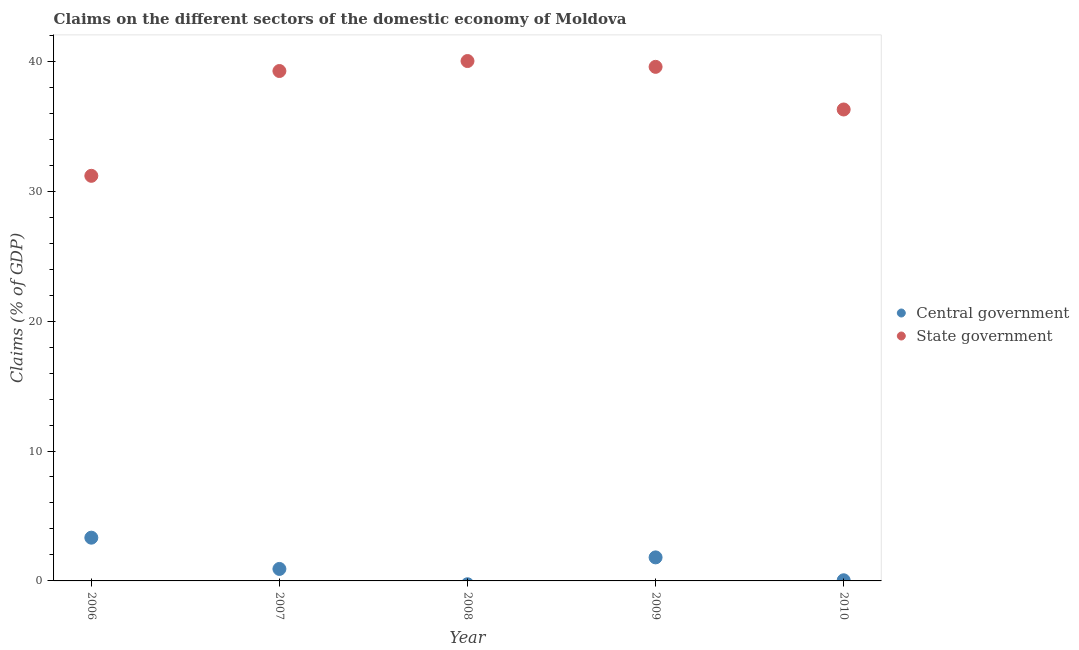How many different coloured dotlines are there?
Provide a short and direct response. 2. Is the number of dotlines equal to the number of legend labels?
Your answer should be very brief. No. What is the claims on central government in 2007?
Make the answer very short. 0.92. Across all years, what is the maximum claims on state government?
Your answer should be compact. 40.02. Across all years, what is the minimum claims on state government?
Offer a very short reply. 31.18. In which year was the claims on central government maximum?
Keep it short and to the point. 2006. What is the total claims on central government in the graph?
Your response must be concise. 6.11. What is the difference between the claims on central government in 2007 and that in 2010?
Your answer should be very brief. 0.87. What is the difference between the claims on central government in 2007 and the claims on state government in 2009?
Give a very brief answer. -38.65. What is the average claims on central government per year?
Your answer should be very brief. 1.22. In the year 2006, what is the difference between the claims on central government and claims on state government?
Provide a short and direct response. -27.85. In how many years, is the claims on central government greater than 4 %?
Keep it short and to the point. 0. What is the ratio of the claims on central government in 2006 to that in 2007?
Provide a short and direct response. 3.61. Is the claims on state government in 2006 less than that in 2009?
Your answer should be very brief. Yes. What is the difference between the highest and the second highest claims on state government?
Your answer should be very brief. 0.45. What is the difference between the highest and the lowest claims on state government?
Keep it short and to the point. 8.84. In how many years, is the claims on central government greater than the average claims on central government taken over all years?
Your answer should be compact. 2. Is the claims on central government strictly greater than the claims on state government over the years?
Give a very brief answer. No. How many dotlines are there?
Your response must be concise. 2. Are the values on the major ticks of Y-axis written in scientific E-notation?
Your answer should be very brief. No. Does the graph contain any zero values?
Give a very brief answer. Yes. What is the title of the graph?
Ensure brevity in your answer.  Claims on the different sectors of the domestic economy of Moldova. What is the label or title of the Y-axis?
Provide a succinct answer. Claims (% of GDP). What is the Claims (% of GDP) in Central government in 2006?
Your answer should be very brief. 3.33. What is the Claims (% of GDP) of State government in 2006?
Your response must be concise. 31.18. What is the Claims (% of GDP) of Central government in 2007?
Offer a very short reply. 0.92. What is the Claims (% of GDP) in State government in 2007?
Provide a short and direct response. 39.25. What is the Claims (% of GDP) in Central government in 2008?
Offer a terse response. 0. What is the Claims (% of GDP) of State government in 2008?
Keep it short and to the point. 40.02. What is the Claims (% of GDP) of Central government in 2009?
Make the answer very short. 1.81. What is the Claims (% of GDP) of State government in 2009?
Your answer should be very brief. 39.57. What is the Claims (% of GDP) in Central government in 2010?
Keep it short and to the point. 0.05. What is the Claims (% of GDP) in State government in 2010?
Provide a succinct answer. 36.29. Across all years, what is the maximum Claims (% of GDP) in Central government?
Your response must be concise. 3.33. Across all years, what is the maximum Claims (% of GDP) in State government?
Your answer should be very brief. 40.02. Across all years, what is the minimum Claims (% of GDP) in Central government?
Offer a very short reply. 0. Across all years, what is the minimum Claims (% of GDP) of State government?
Offer a terse response. 31.18. What is the total Claims (% of GDP) in Central government in the graph?
Ensure brevity in your answer.  6.11. What is the total Claims (% of GDP) of State government in the graph?
Your response must be concise. 186.3. What is the difference between the Claims (% of GDP) in Central government in 2006 and that in 2007?
Make the answer very short. 2.41. What is the difference between the Claims (% of GDP) in State government in 2006 and that in 2007?
Provide a short and direct response. -8.07. What is the difference between the Claims (% of GDP) of State government in 2006 and that in 2008?
Provide a succinct answer. -8.84. What is the difference between the Claims (% of GDP) of Central government in 2006 and that in 2009?
Your answer should be very brief. 1.52. What is the difference between the Claims (% of GDP) of State government in 2006 and that in 2009?
Your answer should be very brief. -8.39. What is the difference between the Claims (% of GDP) of Central government in 2006 and that in 2010?
Offer a terse response. 3.28. What is the difference between the Claims (% of GDP) in State government in 2006 and that in 2010?
Give a very brief answer. -5.11. What is the difference between the Claims (% of GDP) in State government in 2007 and that in 2008?
Keep it short and to the point. -0.77. What is the difference between the Claims (% of GDP) of Central government in 2007 and that in 2009?
Make the answer very short. -0.89. What is the difference between the Claims (% of GDP) of State government in 2007 and that in 2009?
Provide a succinct answer. -0.32. What is the difference between the Claims (% of GDP) of Central government in 2007 and that in 2010?
Provide a succinct answer. 0.87. What is the difference between the Claims (% of GDP) in State government in 2007 and that in 2010?
Your answer should be very brief. 2.96. What is the difference between the Claims (% of GDP) of State government in 2008 and that in 2009?
Offer a very short reply. 0.45. What is the difference between the Claims (% of GDP) of State government in 2008 and that in 2010?
Make the answer very short. 3.73. What is the difference between the Claims (% of GDP) in Central government in 2009 and that in 2010?
Your answer should be very brief. 1.76. What is the difference between the Claims (% of GDP) of State government in 2009 and that in 2010?
Offer a terse response. 3.28. What is the difference between the Claims (% of GDP) of Central government in 2006 and the Claims (% of GDP) of State government in 2007?
Your answer should be very brief. -35.92. What is the difference between the Claims (% of GDP) of Central government in 2006 and the Claims (% of GDP) of State government in 2008?
Keep it short and to the point. -36.69. What is the difference between the Claims (% of GDP) in Central government in 2006 and the Claims (% of GDP) in State government in 2009?
Offer a terse response. -36.24. What is the difference between the Claims (% of GDP) of Central government in 2006 and the Claims (% of GDP) of State government in 2010?
Ensure brevity in your answer.  -32.96. What is the difference between the Claims (% of GDP) of Central government in 2007 and the Claims (% of GDP) of State government in 2008?
Keep it short and to the point. -39.09. What is the difference between the Claims (% of GDP) in Central government in 2007 and the Claims (% of GDP) in State government in 2009?
Provide a short and direct response. -38.65. What is the difference between the Claims (% of GDP) in Central government in 2007 and the Claims (% of GDP) in State government in 2010?
Your response must be concise. -35.36. What is the difference between the Claims (% of GDP) of Central government in 2009 and the Claims (% of GDP) of State government in 2010?
Ensure brevity in your answer.  -34.48. What is the average Claims (% of GDP) of Central government per year?
Your answer should be compact. 1.22. What is the average Claims (% of GDP) in State government per year?
Make the answer very short. 37.26. In the year 2006, what is the difference between the Claims (% of GDP) of Central government and Claims (% of GDP) of State government?
Make the answer very short. -27.85. In the year 2007, what is the difference between the Claims (% of GDP) in Central government and Claims (% of GDP) in State government?
Offer a terse response. -38.33. In the year 2009, what is the difference between the Claims (% of GDP) of Central government and Claims (% of GDP) of State government?
Your answer should be very brief. -37.76. In the year 2010, what is the difference between the Claims (% of GDP) in Central government and Claims (% of GDP) in State government?
Make the answer very short. -36.24. What is the ratio of the Claims (% of GDP) of Central government in 2006 to that in 2007?
Offer a terse response. 3.61. What is the ratio of the Claims (% of GDP) of State government in 2006 to that in 2007?
Give a very brief answer. 0.79. What is the ratio of the Claims (% of GDP) in State government in 2006 to that in 2008?
Keep it short and to the point. 0.78. What is the ratio of the Claims (% of GDP) of Central government in 2006 to that in 2009?
Give a very brief answer. 1.84. What is the ratio of the Claims (% of GDP) in State government in 2006 to that in 2009?
Keep it short and to the point. 0.79. What is the ratio of the Claims (% of GDP) of Central government in 2006 to that in 2010?
Offer a very short reply. 67.5. What is the ratio of the Claims (% of GDP) in State government in 2006 to that in 2010?
Offer a terse response. 0.86. What is the ratio of the Claims (% of GDP) of State government in 2007 to that in 2008?
Your response must be concise. 0.98. What is the ratio of the Claims (% of GDP) in Central government in 2007 to that in 2009?
Ensure brevity in your answer.  0.51. What is the ratio of the Claims (% of GDP) of State government in 2007 to that in 2009?
Keep it short and to the point. 0.99. What is the ratio of the Claims (% of GDP) of Central government in 2007 to that in 2010?
Keep it short and to the point. 18.7. What is the ratio of the Claims (% of GDP) in State government in 2007 to that in 2010?
Provide a short and direct response. 1.08. What is the ratio of the Claims (% of GDP) in State government in 2008 to that in 2009?
Provide a short and direct response. 1.01. What is the ratio of the Claims (% of GDP) in State government in 2008 to that in 2010?
Offer a terse response. 1.1. What is the ratio of the Claims (% of GDP) of Central government in 2009 to that in 2010?
Provide a short and direct response. 36.74. What is the ratio of the Claims (% of GDP) in State government in 2009 to that in 2010?
Your response must be concise. 1.09. What is the difference between the highest and the second highest Claims (% of GDP) in Central government?
Offer a terse response. 1.52. What is the difference between the highest and the second highest Claims (% of GDP) in State government?
Offer a terse response. 0.45. What is the difference between the highest and the lowest Claims (% of GDP) in Central government?
Your response must be concise. 3.33. What is the difference between the highest and the lowest Claims (% of GDP) in State government?
Offer a terse response. 8.84. 